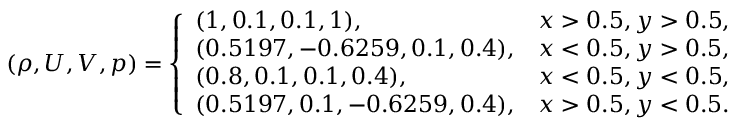<formula> <loc_0><loc_0><loc_500><loc_500>\begin{array} { r } { ( \rho , U , V , p ) = \left \{ \begin{array} { l l } { ( 1 , 0 . 1 , 0 . 1 , 1 ) , } & { x > 0 . 5 , y > 0 . 5 , } \\ { ( 0 . 5 1 9 7 , - 0 . 6 2 5 9 , 0 . 1 , 0 . 4 ) , } & { x < 0 . 5 , y > 0 . 5 , } \\ { ( 0 . 8 , 0 . 1 , 0 . 1 , 0 . 4 ) , } & { x < 0 . 5 , y < 0 . 5 , } \\ { ( 0 . 5 1 9 7 , 0 . 1 , - 0 . 6 2 5 9 , 0 . 4 ) , } & { x > 0 . 5 , y < 0 . 5 . } \end{array} } \end{array}</formula> 